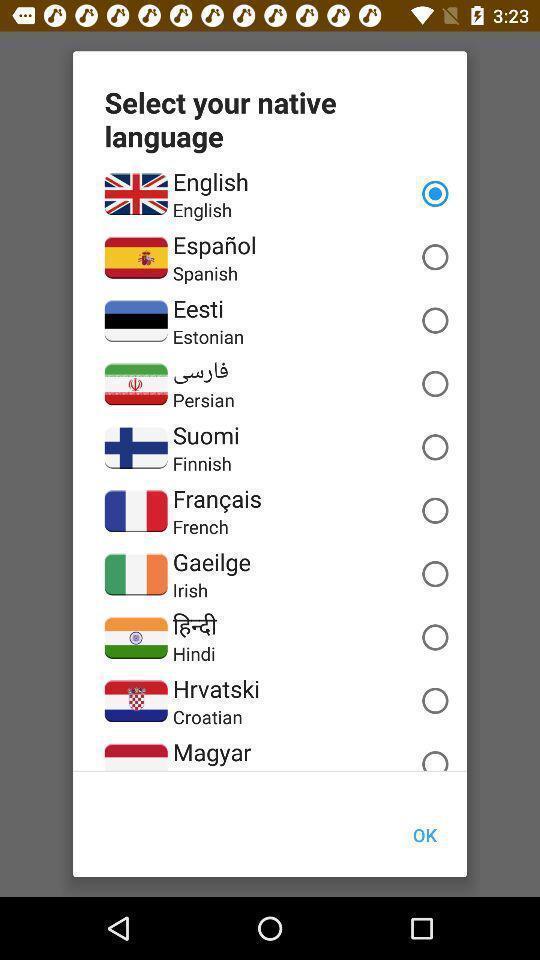Explain what's happening in this screen capture. Pop-up to select a language. 